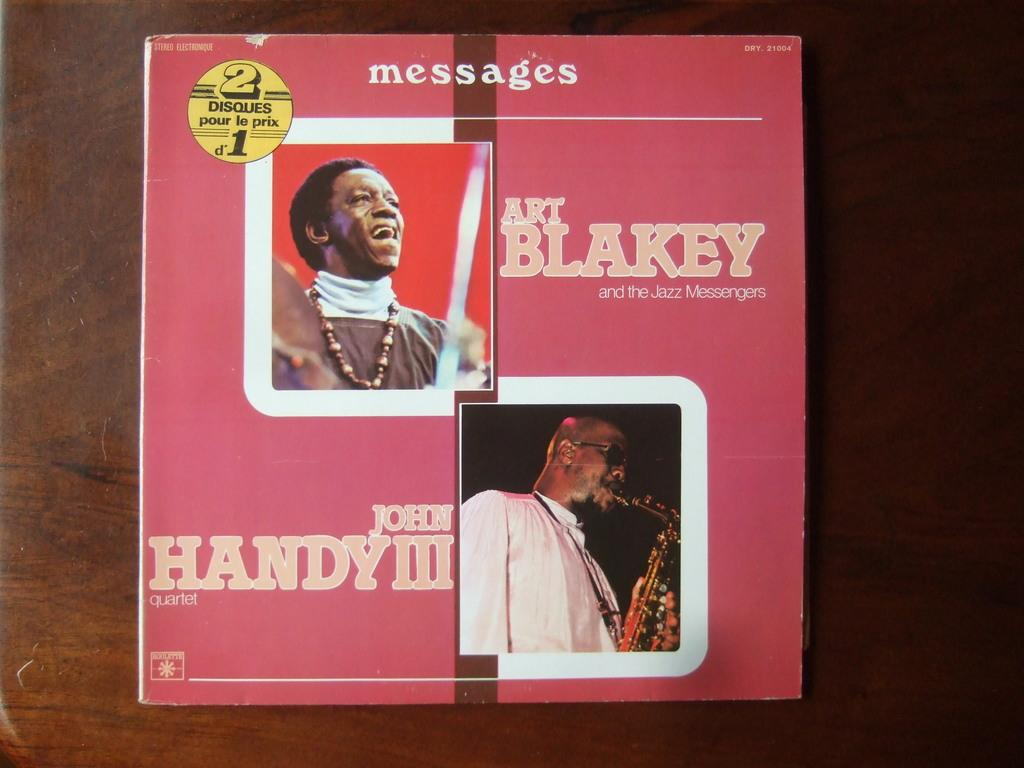<image>
Relay a brief, clear account of the picture shown. the cover of a CD for Messages Art Blakey and John Handy III 